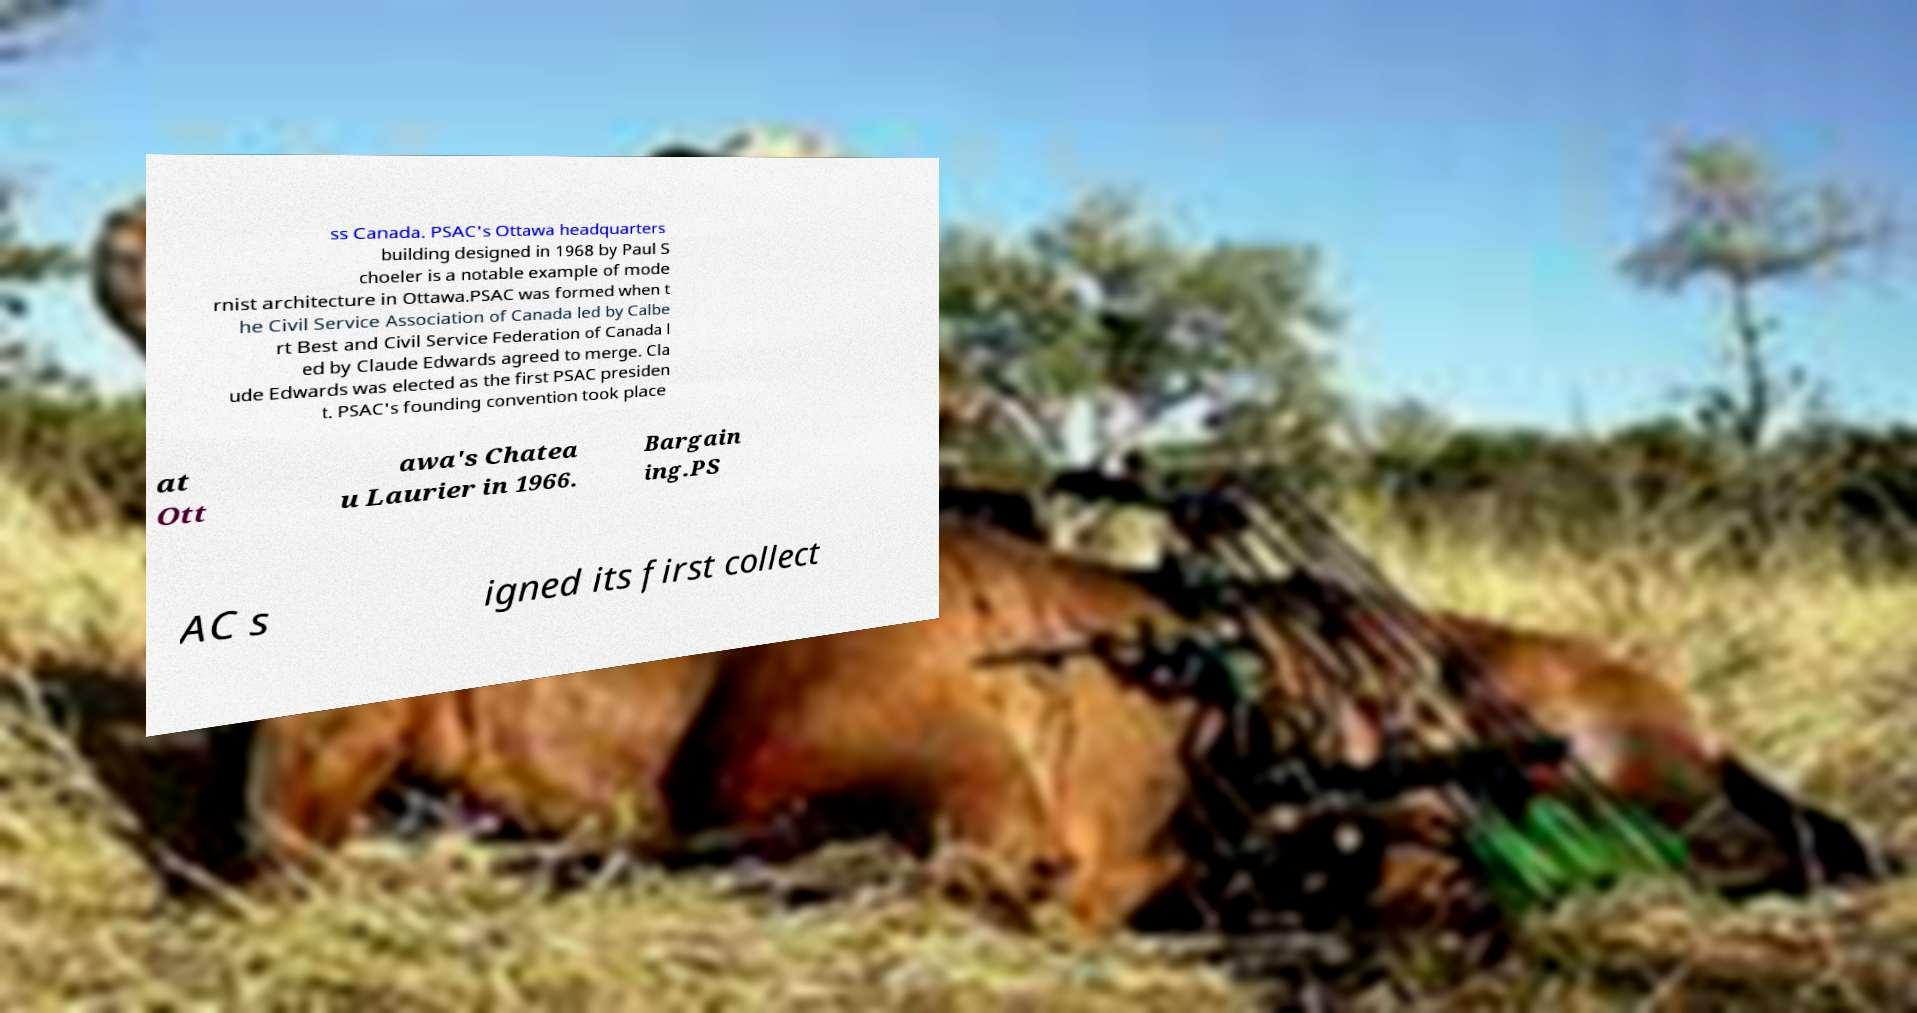Please identify and transcribe the text found in this image. ss Canada. PSAC's Ottawa headquarters building designed in 1968 by Paul S choeler is a notable example of mode rnist architecture in Ottawa.PSAC was formed when t he Civil Service Association of Canada led by Calbe rt Best and Civil Service Federation of Canada l ed by Claude Edwards agreed to merge. Cla ude Edwards was elected as the first PSAC presiden t. PSAC's founding convention took place at Ott awa's Chatea u Laurier in 1966. Bargain ing.PS AC s igned its first collect 